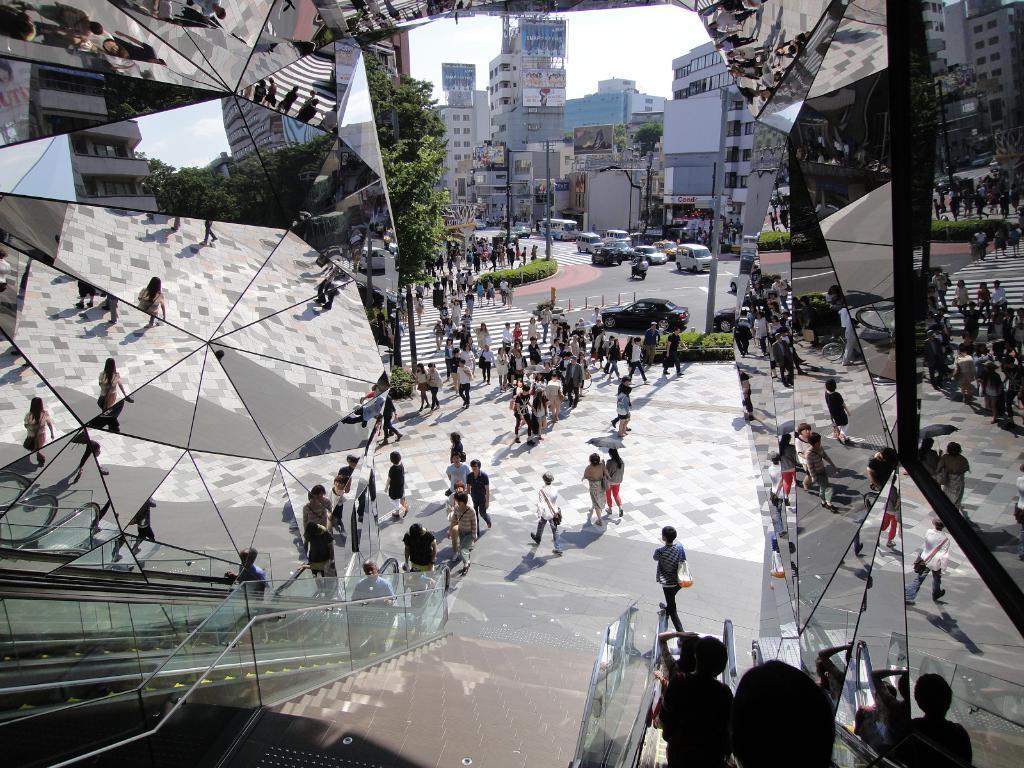Please provide a concise description of this image. In this image there are some mirrors at left side of the image and right side of this image as well ,and there are some persons are standing in middle of this image. There is a tree at middle of this image and there are some buildings at top of this image and there are some stairs at bottom of this image. There are some cars at middle of this image and there is a sky at top of this image. 